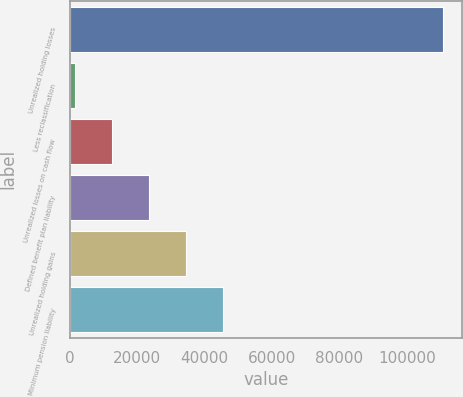Convert chart to OTSL. <chart><loc_0><loc_0><loc_500><loc_500><bar_chart><fcel>Unrealized holding losses<fcel>Less reclassification<fcel>Unrealized losses on cash flow<fcel>Defined benefit plan liability<fcel>Unrealized holding gains<fcel>Minimum pension liability<nl><fcel>110883<fcel>1590<fcel>12519.3<fcel>23448.6<fcel>34377.9<fcel>45307.2<nl></chart> 